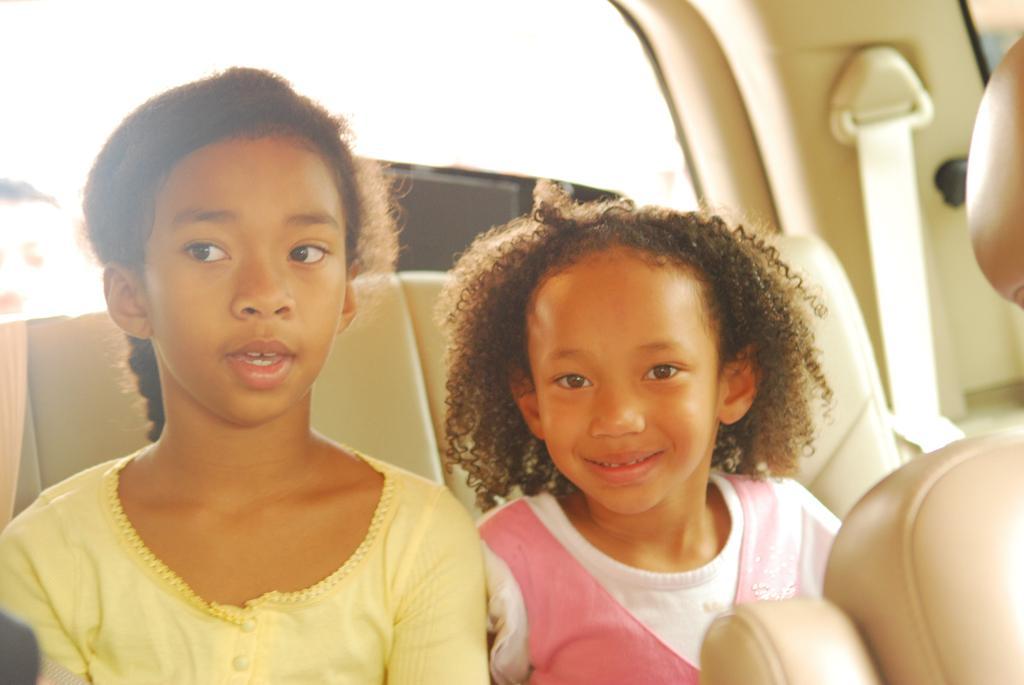Could you give a brief overview of what you see in this image? It is an inside view of a vehicle. Here we can see two kids are sitting. On the right side of the image, we can see a kid is watching and smiling. Here there are few seats, seat belt, glass object and few things. 